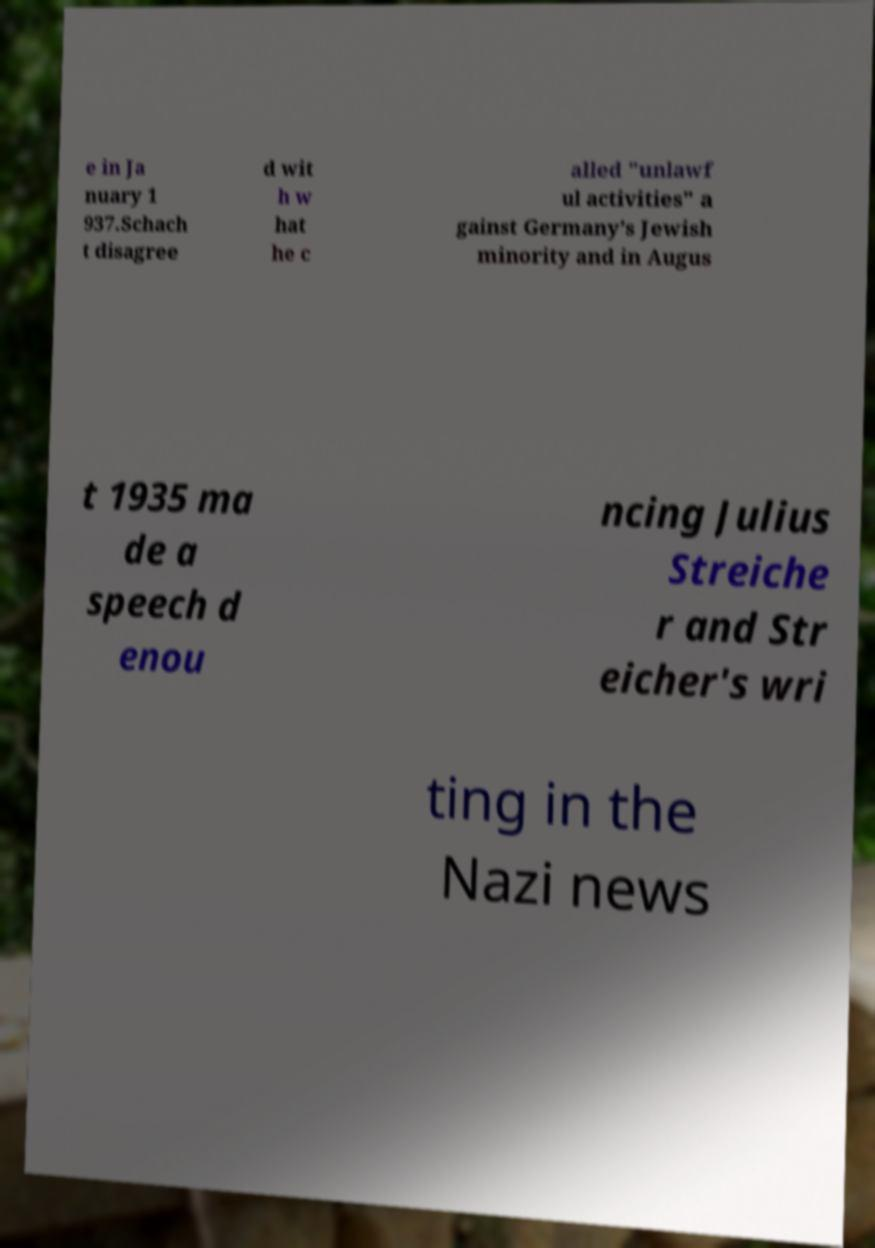Could you extract and type out the text from this image? e in Ja nuary 1 937.Schach t disagree d wit h w hat he c alled "unlawf ul activities" a gainst Germany's Jewish minority and in Augus t 1935 ma de a speech d enou ncing Julius Streiche r and Str eicher's wri ting in the Nazi news 